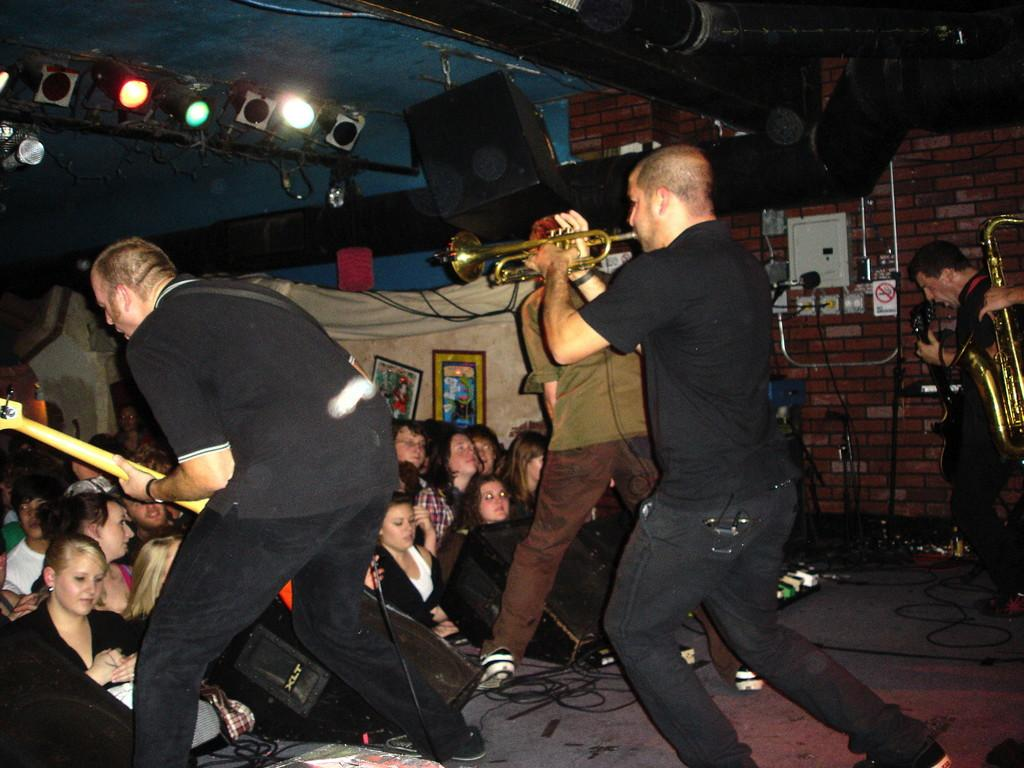What are the people in the image doing? The people in the image are playing with musical instruments. Can you describe the musical instruments they are using? The musical instruments are different from each other. Where is the sofa located in the image? There is no sofa present in the image. What type of angle is being played in the volleyball game in the image? There is no volleyball game present in the image. 